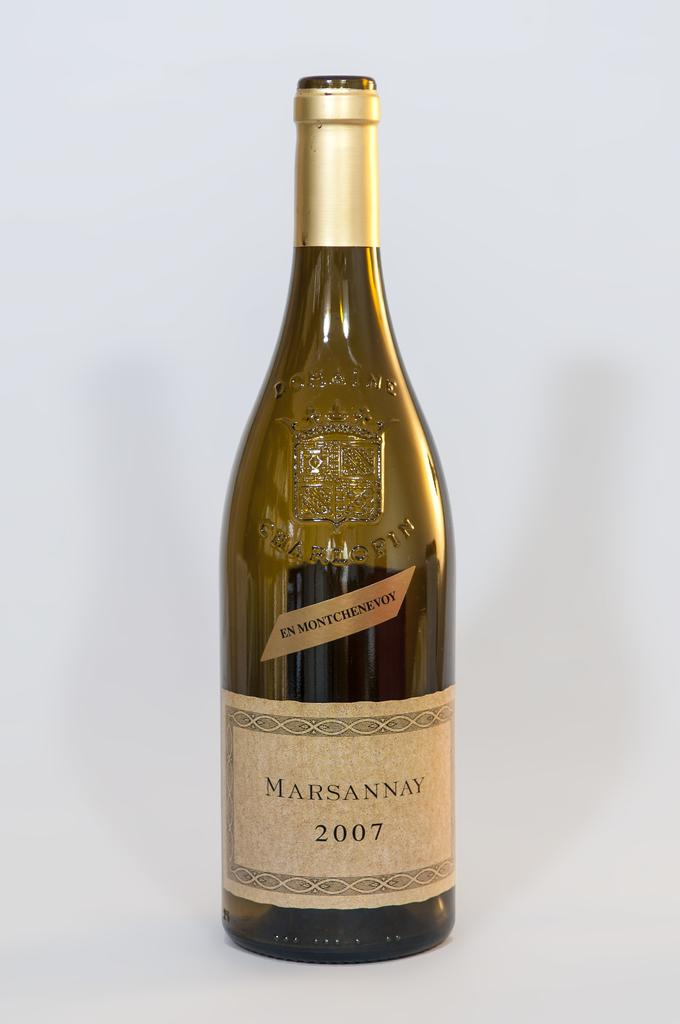Provide a one-sentence caption for the provided image. a wine bottle with a label on it that says ' marsannay 2007'. 